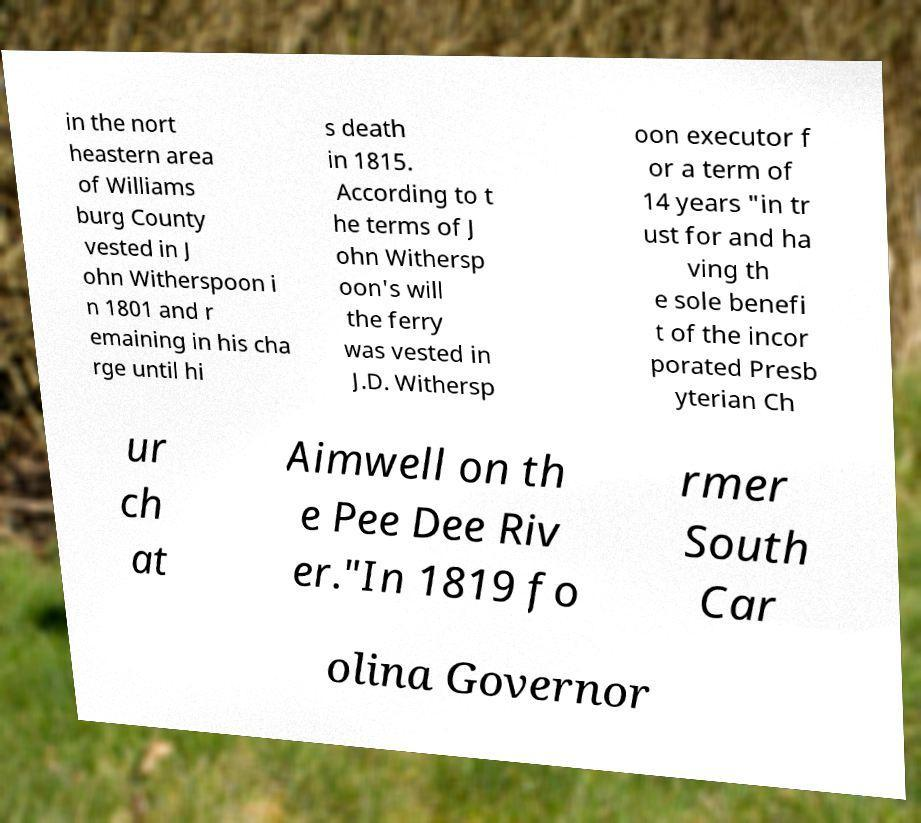Could you assist in decoding the text presented in this image and type it out clearly? in the nort heastern area of Williams burg County vested in J ohn Witherspoon i n 1801 and r emaining in his cha rge until hi s death in 1815. According to t he terms of J ohn Withersp oon's will the ferry was vested in J.D. Withersp oon executor f or a term of 14 years "in tr ust for and ha ving th e sole benefi t of the incor porated Presb yterian Ch ur ch at Aimwell on th e Pee Dee Riv er."In 1819 fo rmer South Car olina Governor 